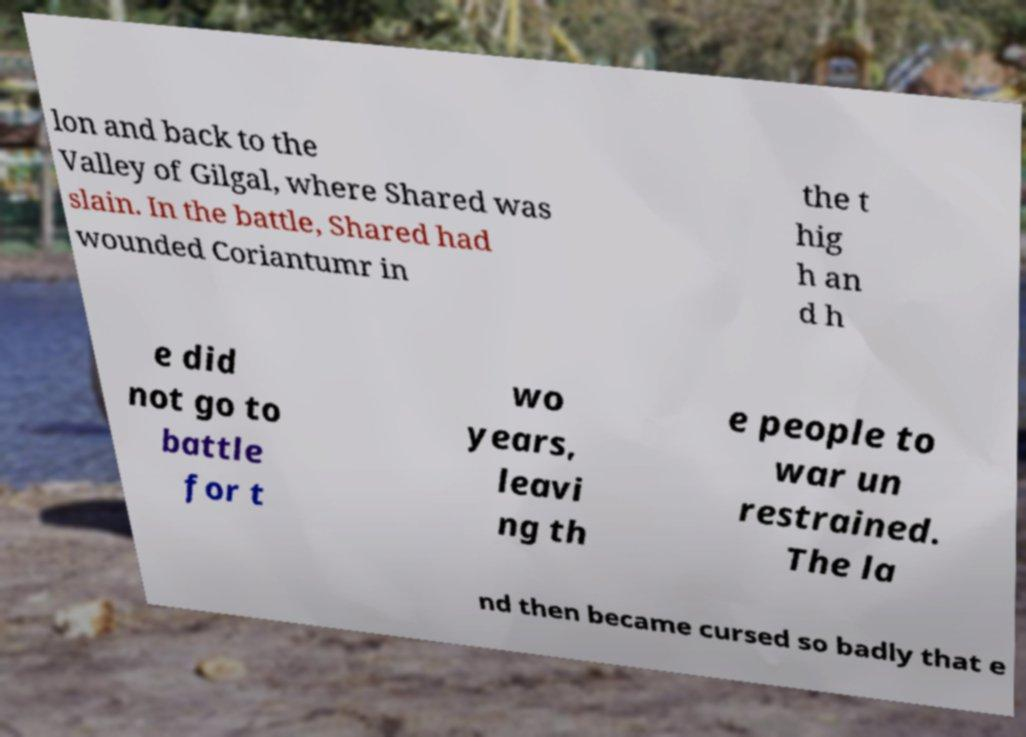I need the written content from this picture converted into text. Can you do that? lon and back to the Valley of Gilgal, where Shared was slain. In the battle, Shared had wounded Coriantumr in the t hig h an d h e did not go to battle for t wo years, leavi ng th e people to war un restrained. The la nd then became cursed so badly that e 